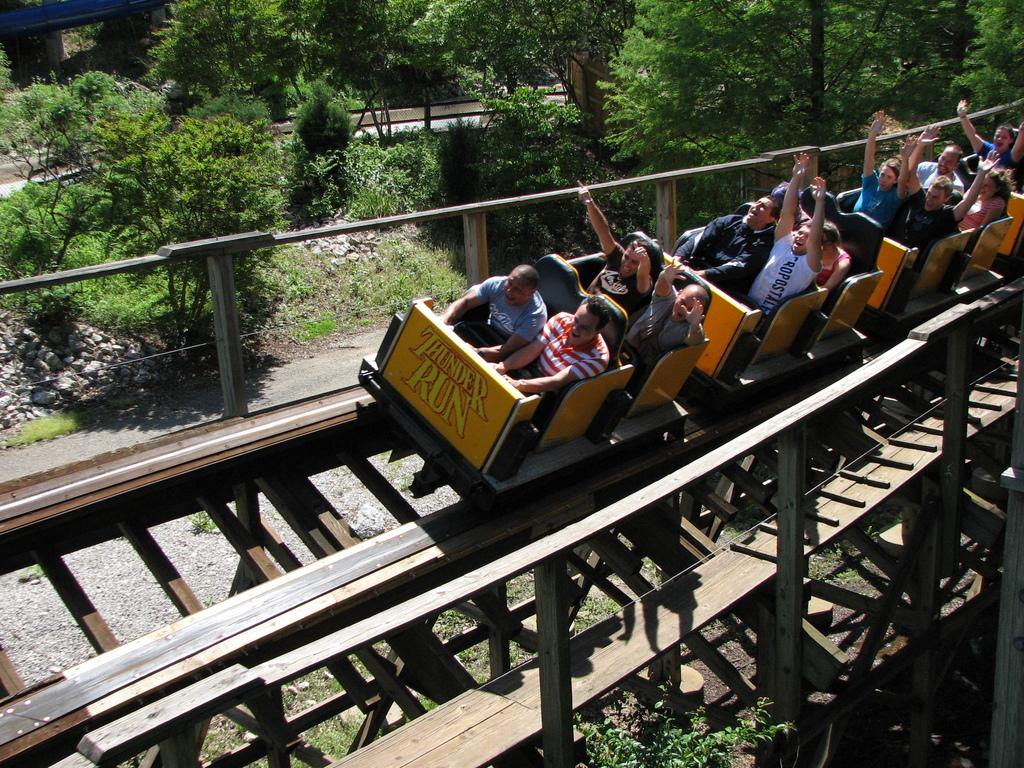Provide a one-sentence caption for the provided image. an image of a roller coaster called 'THUNDER RUN' with people on it on the tracks. 